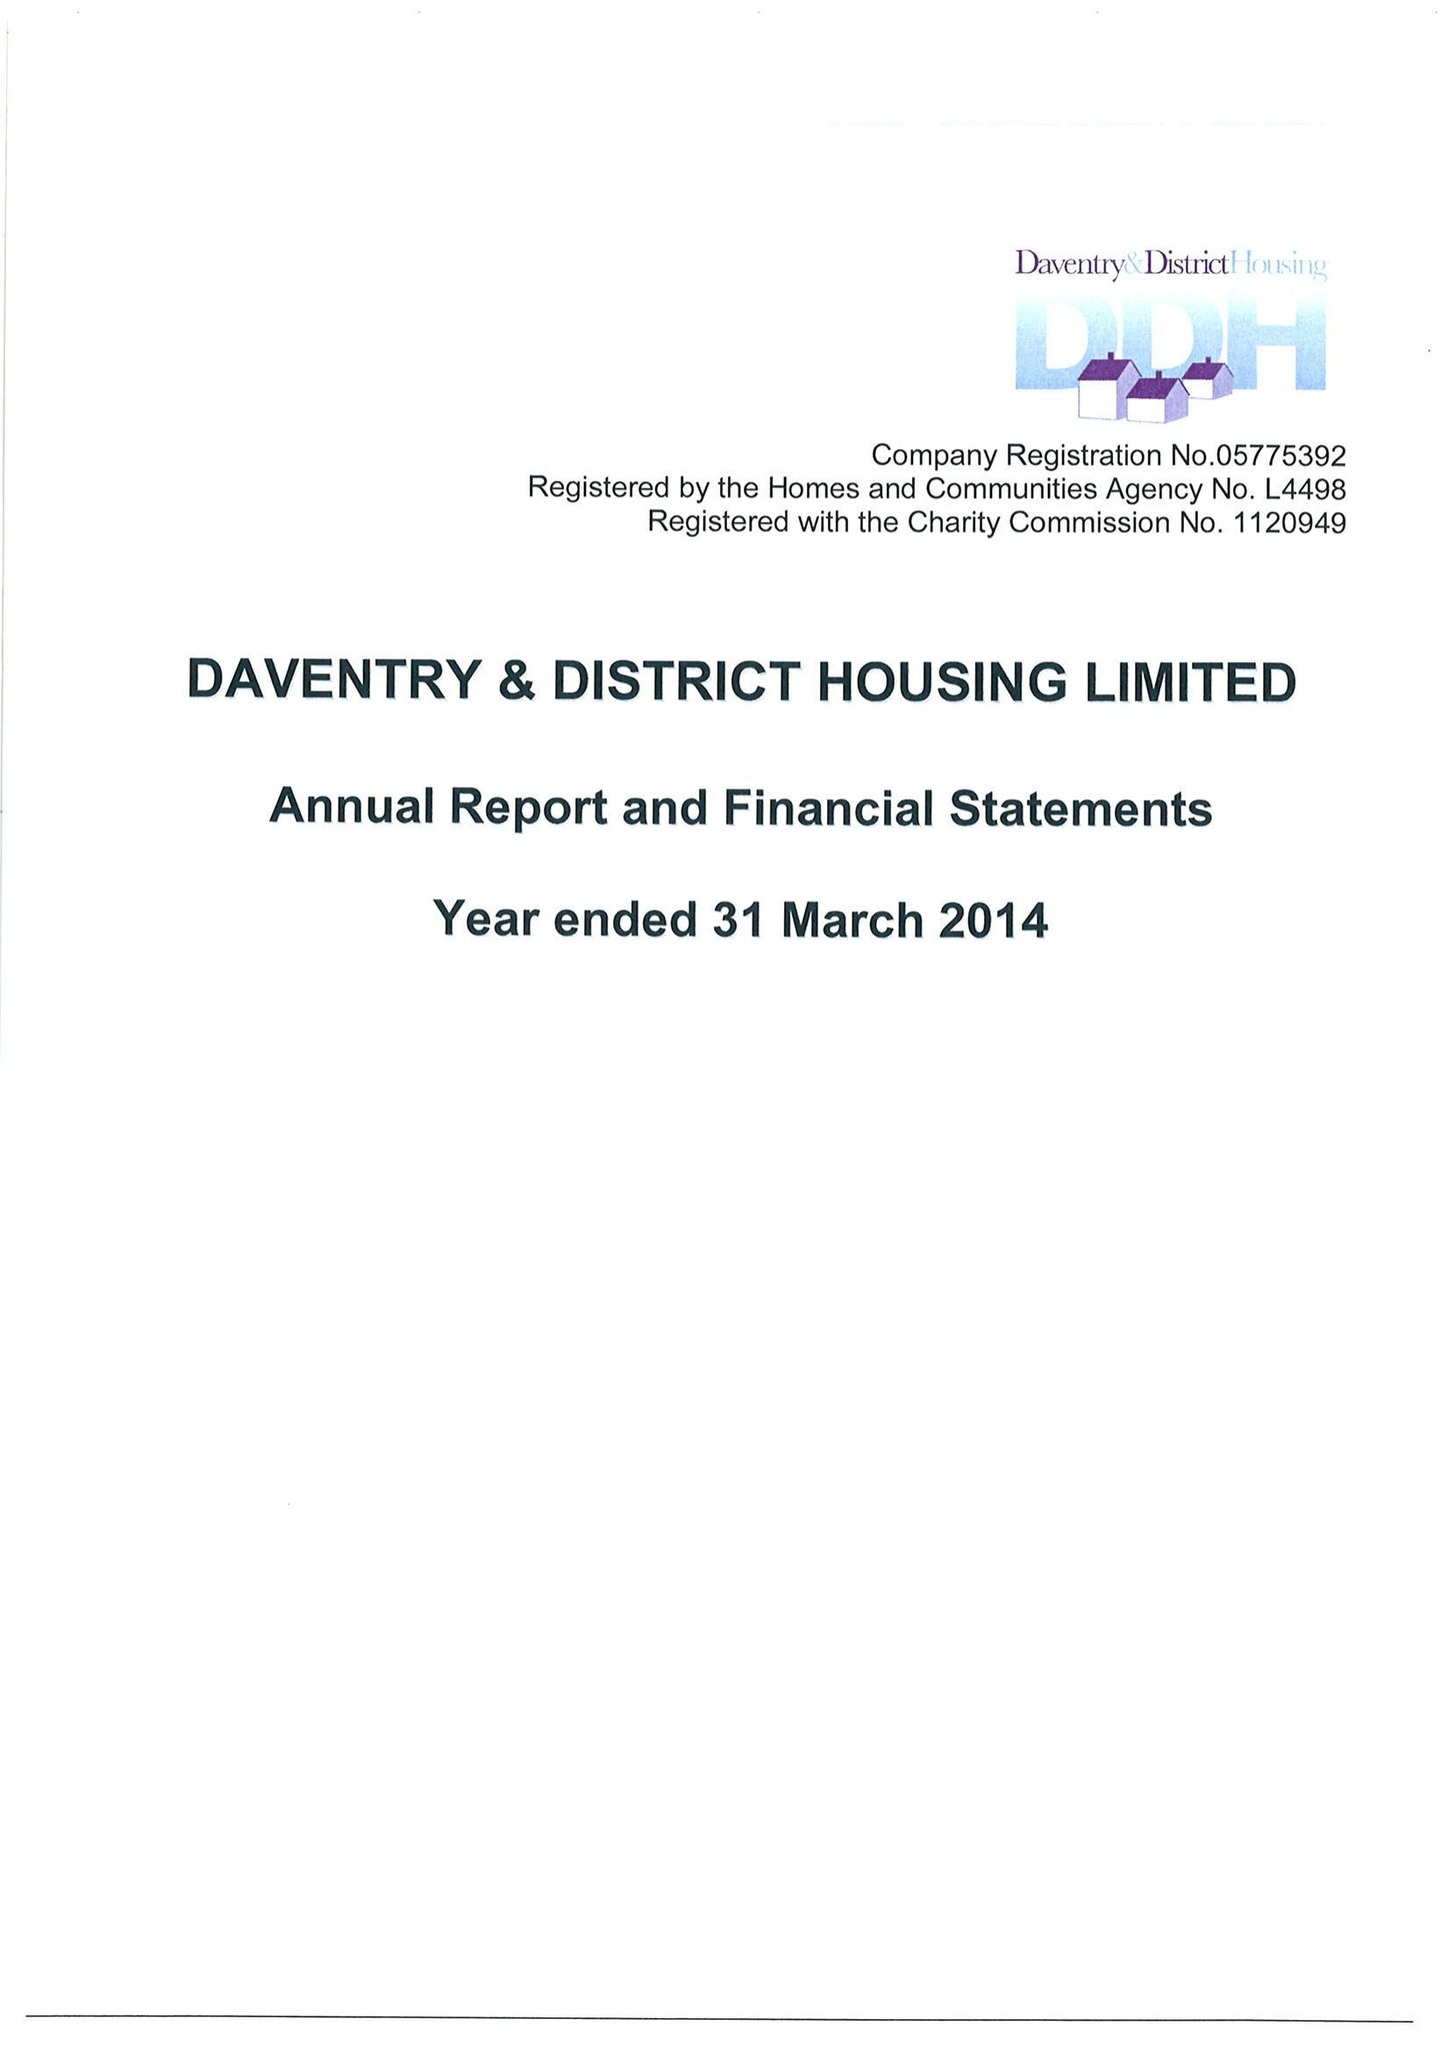What is the value for the address__post_town?
Answer the question using a single word or phrase. RIPLEY 